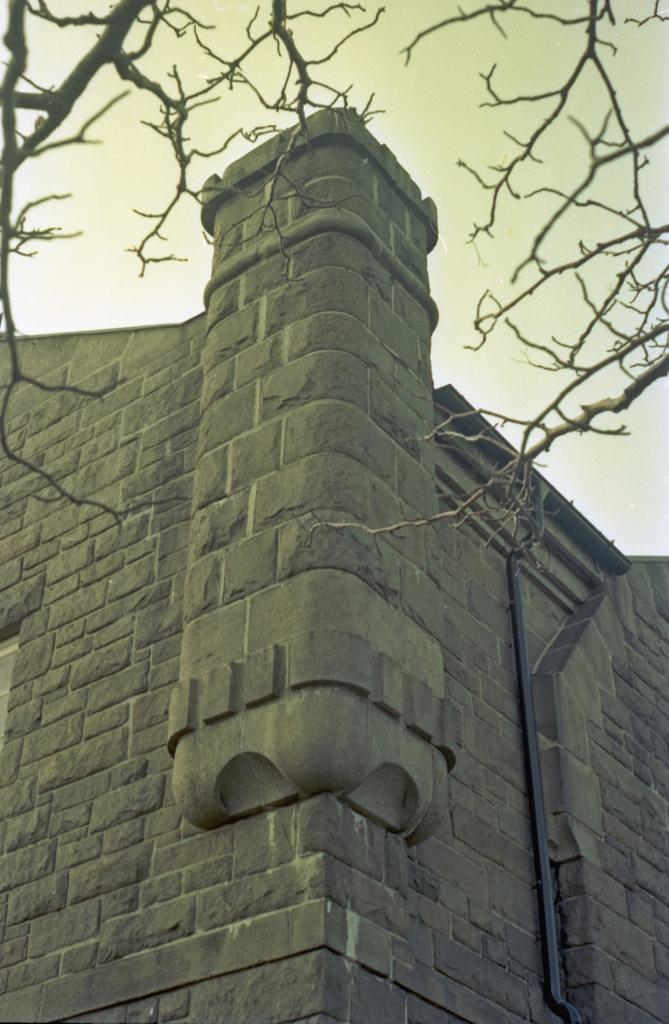Describe this image in one or two sentences. In this image we can see a pipe on the wall, branches of a tree and sky. 